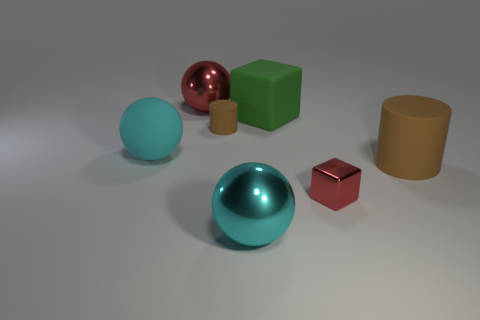Can you infer anything about the environment outside of the immediate view? Given the absence of any distinguishing features or context beyond the objects, it's difficult to infer anything about the larger environment—it seems to be an abstract or controlled space without specific indicators of a real-world location. 